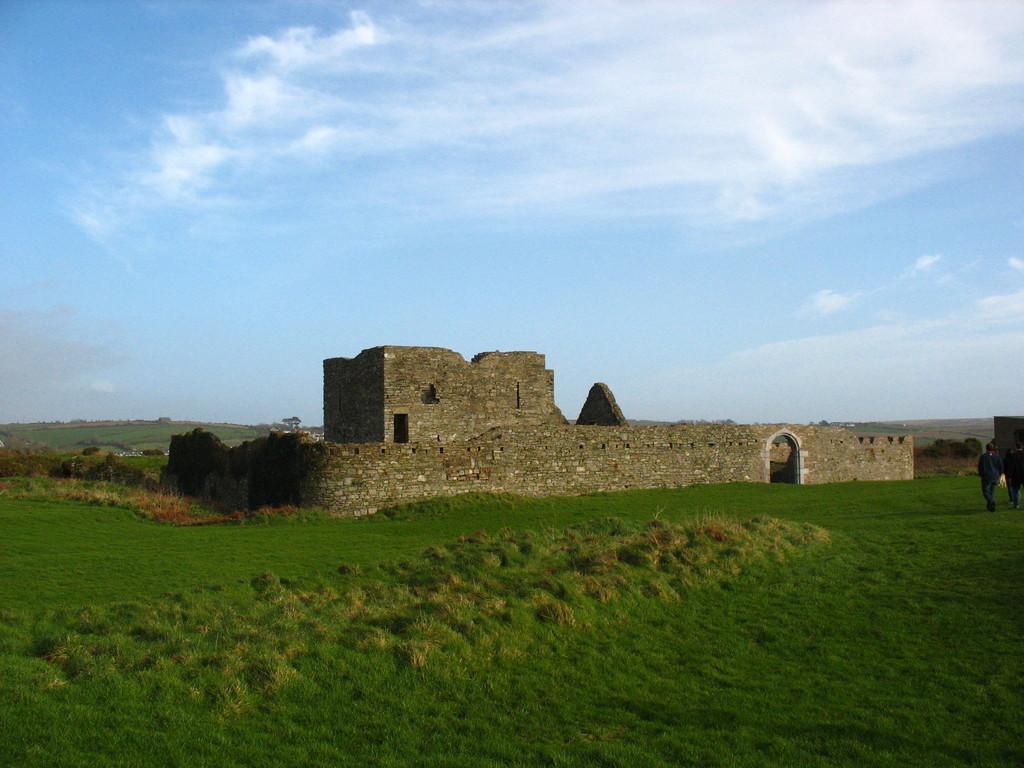Can you describe this image briefly? At the bottom of the image there is grass. In the center of the image there is stone structure. In the background of the image there is sky and clouds. To the right side of the image there are people walking. 